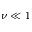<formula> <loc_0><loc_0><loc_500><loc_500>\nu \ll 1</formula> 